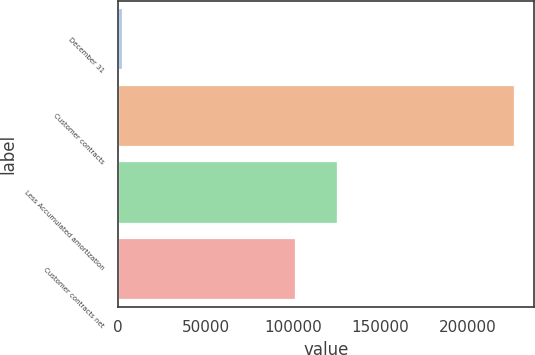Convert chart to OTSL. <chart><loc_0><loc_0><loc_500><loc_500><bar_chart><fcel>December 31<fcel>Customer contracts<fcel>Less Accumulated amortization<fcel>Customer contracts net<nl><fcel>2013<fcel>226717<fcel>125260<fcel>101457<nl></chart> 